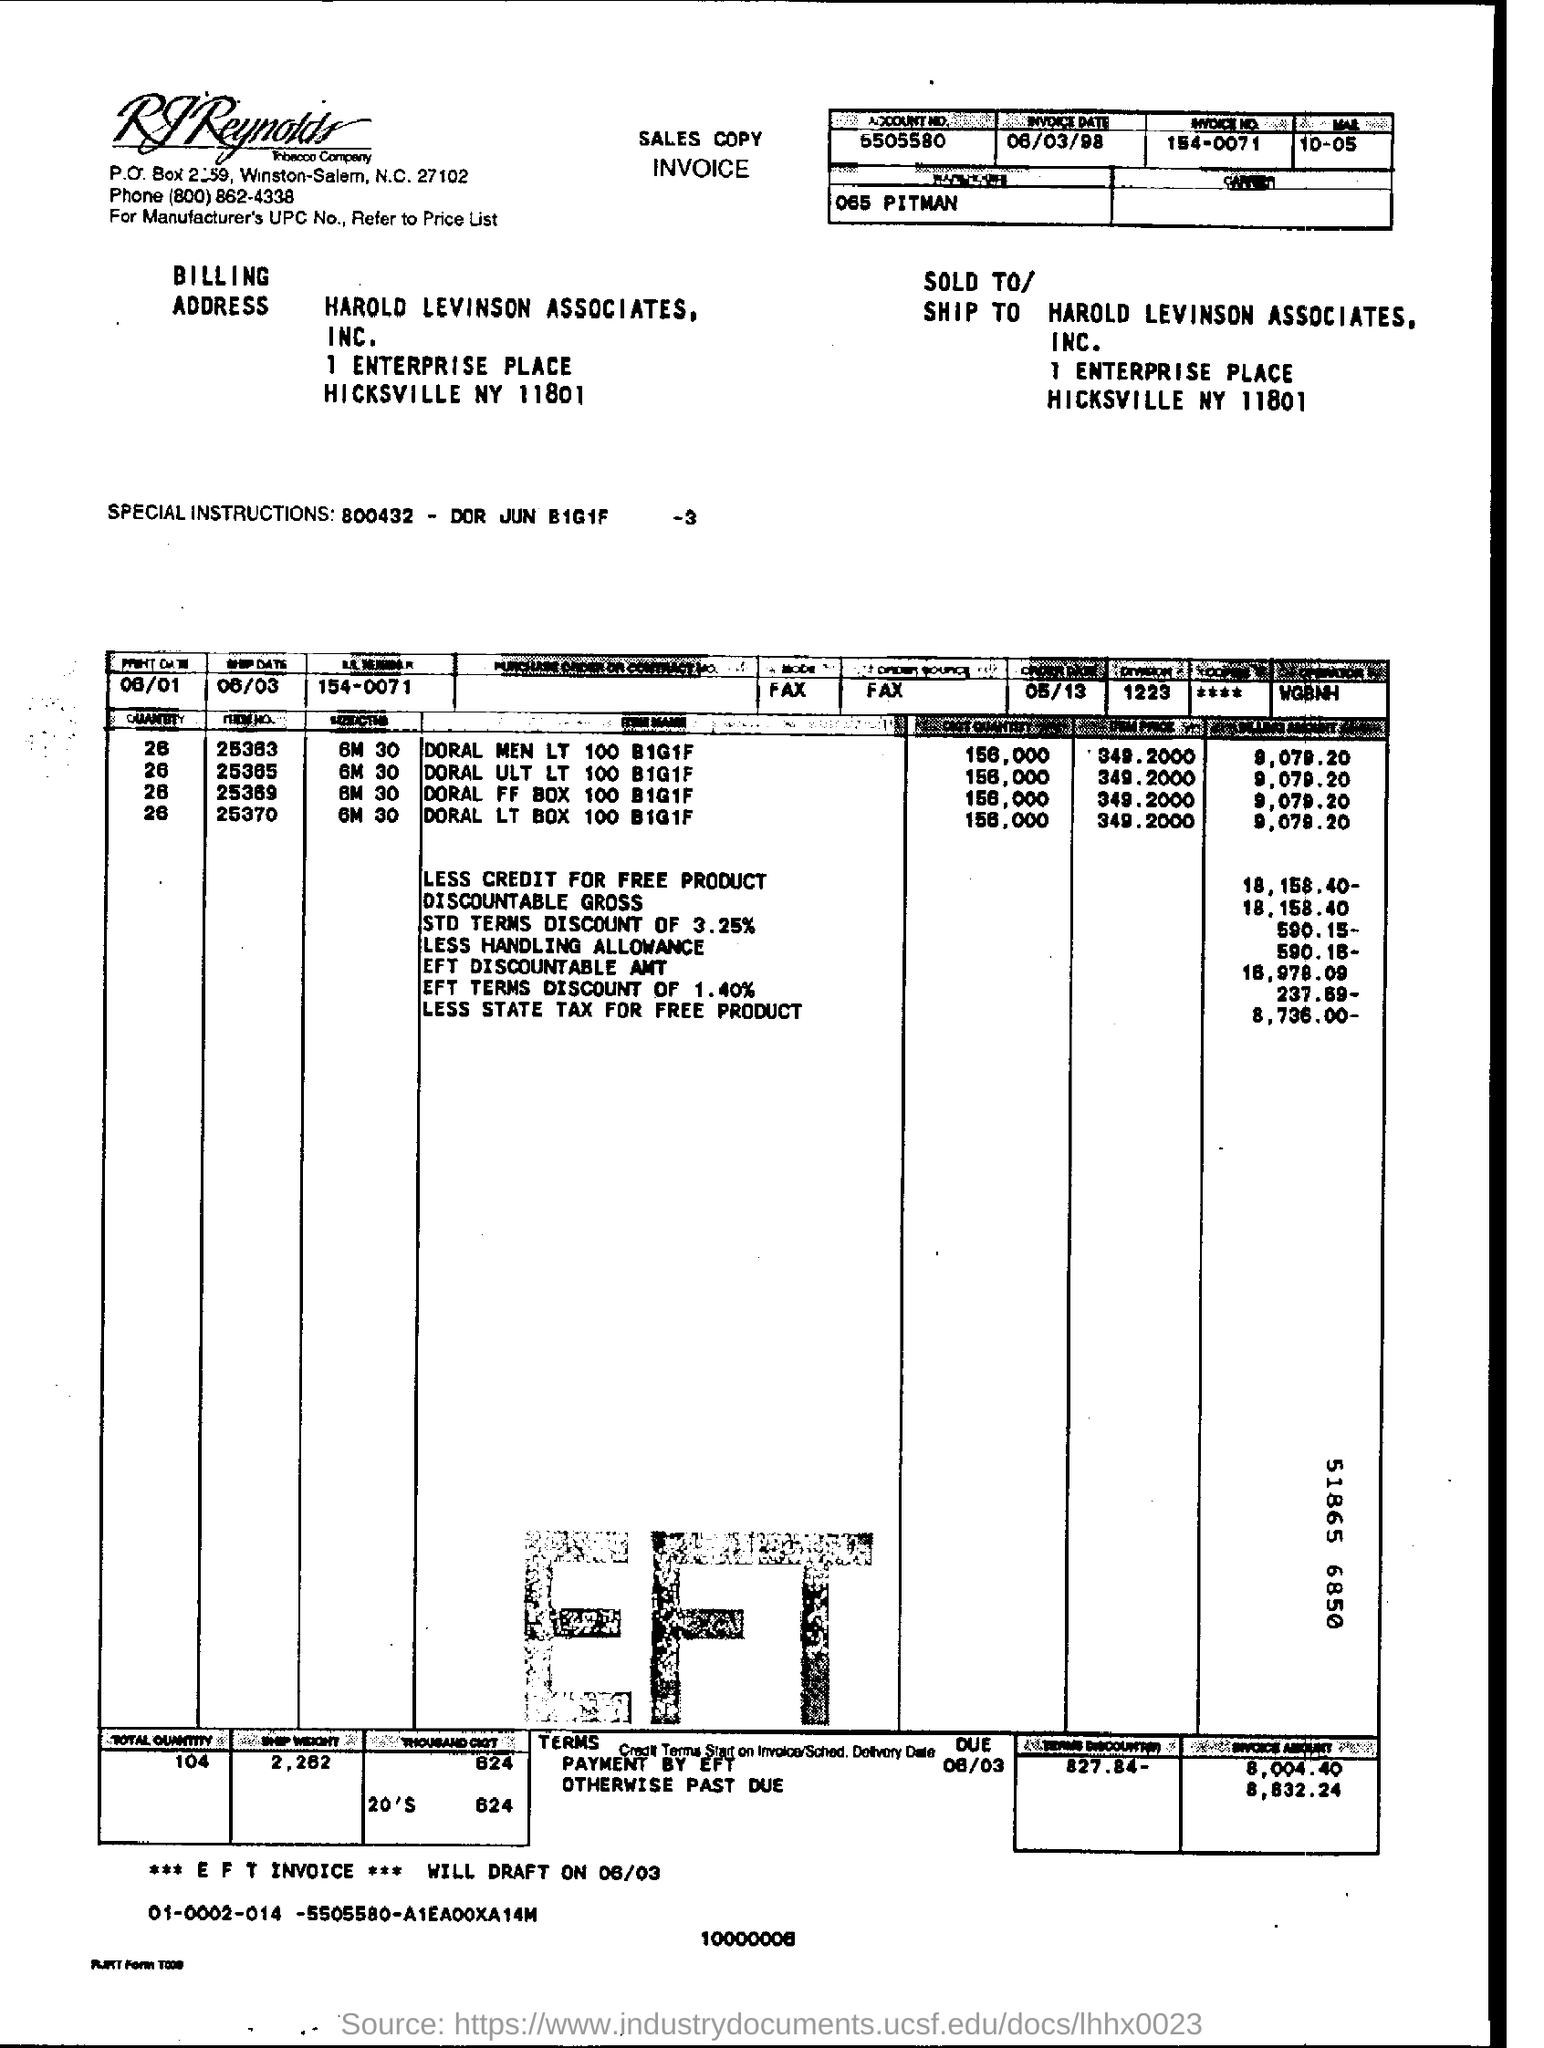Can you tell me what the total amount due for this invoice is? The total amount due for the invoice is $8,632.24. You can confirm this by looking at the bottom right section where it details the terms and payment due. 